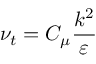<formula> <loc_0><loc_0><loc_500><loc_500>\nu _ { t } = C _ { \mu } \frac { k ^ { 2 } } { \varepsilon }</formula> 